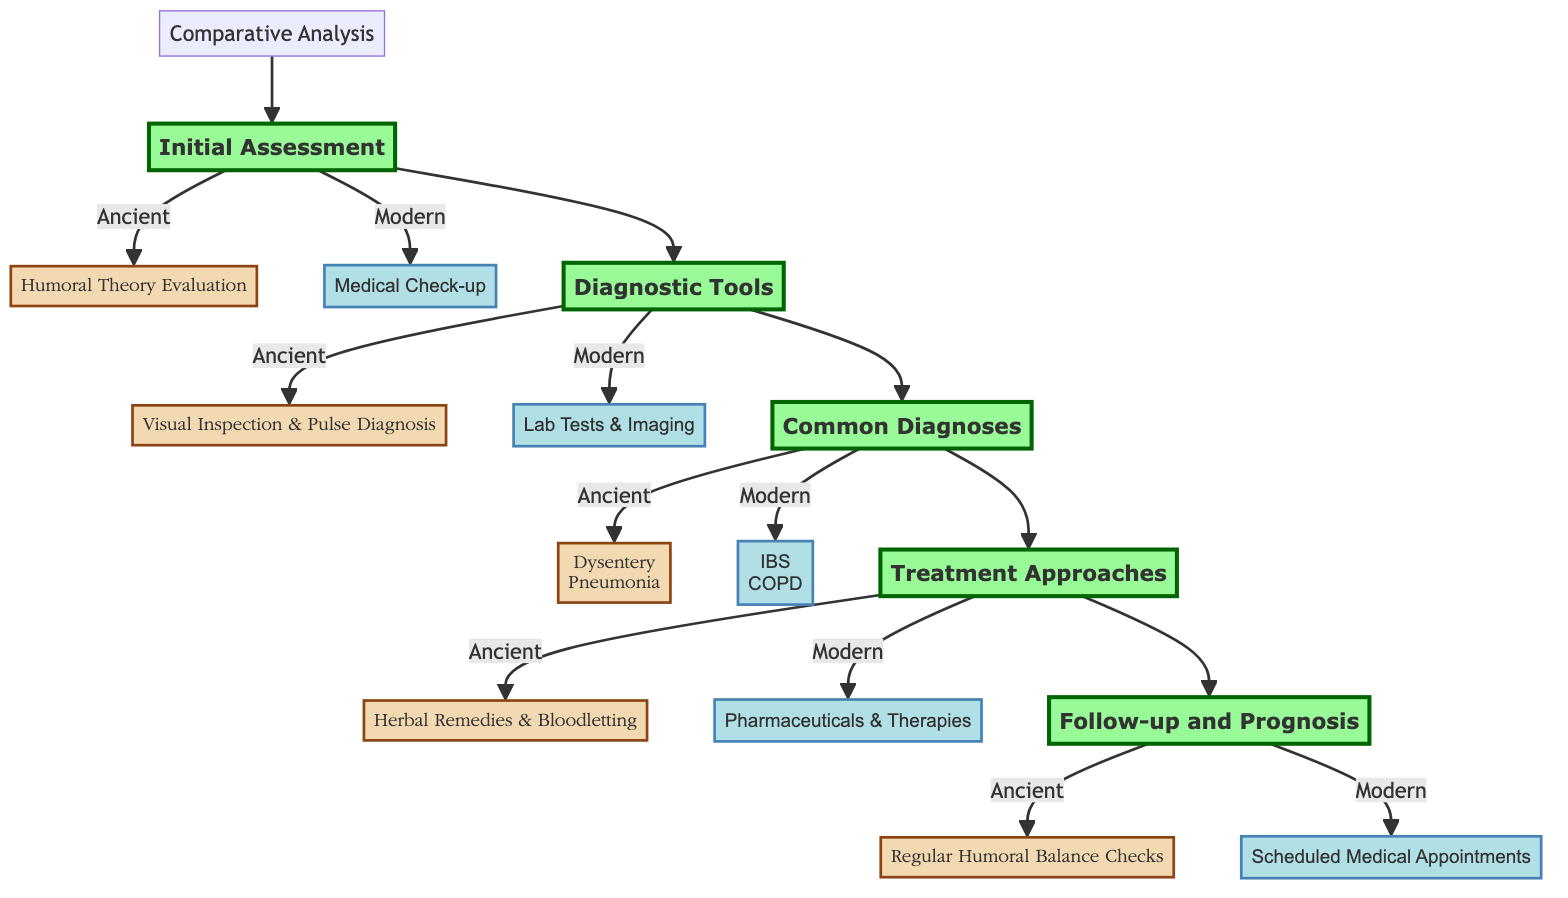What is the first step in the comparative analysis? The first step in the comparative analysis is labeled as "Initial Assessment," where both ancient and modern methods are introduced.
Answer: Initial Assessment What two methods are used for the Initial Assessment? The diagram shows two specific methods used at the Initial Assessment: the ancient method "Humoral Theory Evaluation" and the modern method "Medical Check-up."
Answer: Humoral Theory Evaluation, Medical Check-up How many common diagnoses are listed for ancient practices? Under the "Common Diagnoses" section, there are two conditions listed for ancient practices: Dysentery and Pneumonia, making a total of two.
Answer: 2 What tools are used in the modern diagnostic process? The modern diagnostic tools as indicated in the diagram include "Laboratory Tests and Imaging," which encompasses various modern testing technologies.
Answer: Laboratory Tests and Imaging Which ancient treatment method is mentioned in the Treatment Approaches? In the Treatment Approaches section, the ancient method refers to "Herbal Remedies and Bloodletting" as a way to treat diagnosed conditions.
Answer: Herbal Remedies and Bloodletting How do ancient and modern prognosis approaches differ? The ancient approach to prognosis is "Regular Humoral Balance Checks," whereas the modern approach is "Scheduled Medical Appointments," highlighting a significant operational difference in continued care post-diagnosis.
Answer: Regular Humoral Balance Checks, Scheduled Medical Appointments What is the main goal of the comparative analysis as indicated in the diagram? The main goal of the comparative analysis, as suggested by the title, is to outline the differences and similarities in ancient and modern medical diagnoses and their respective methodologies in Pontevedra.
Answer: Comparative Analysis What type of diagnosis is associated with IBS in modern medicine? In modern medicine, "Irritable Bowel Syndrome (IBS)" is diagnosed using methods such as colonoscopy and patient symptom diary, illustrating the approach taken for this condition.
Answer: Irritable Bowel Syndrome (IBS) 